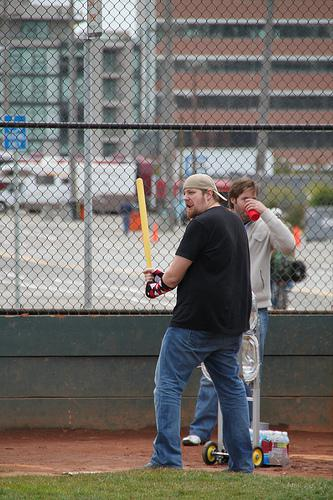Question: where was the picture taken?
Choices:
A. Tennis court.
B. Baseball field.
C. Golf course.
D. Swimming pool.
Answer with the letter. Answer: B Question: what is the man in the black shirt doing?
Choices:
A. Batting.
B. Pitching.
C. Catching.
D. Coaching.
Answer with the letter. Answer: A Question: why is the man in white holding a cup?
Choices:
A. To ask for money.
B. To taste a sample.
C. To drink.
D. To eat ice cream.
Answer with the letter. Answer: C 